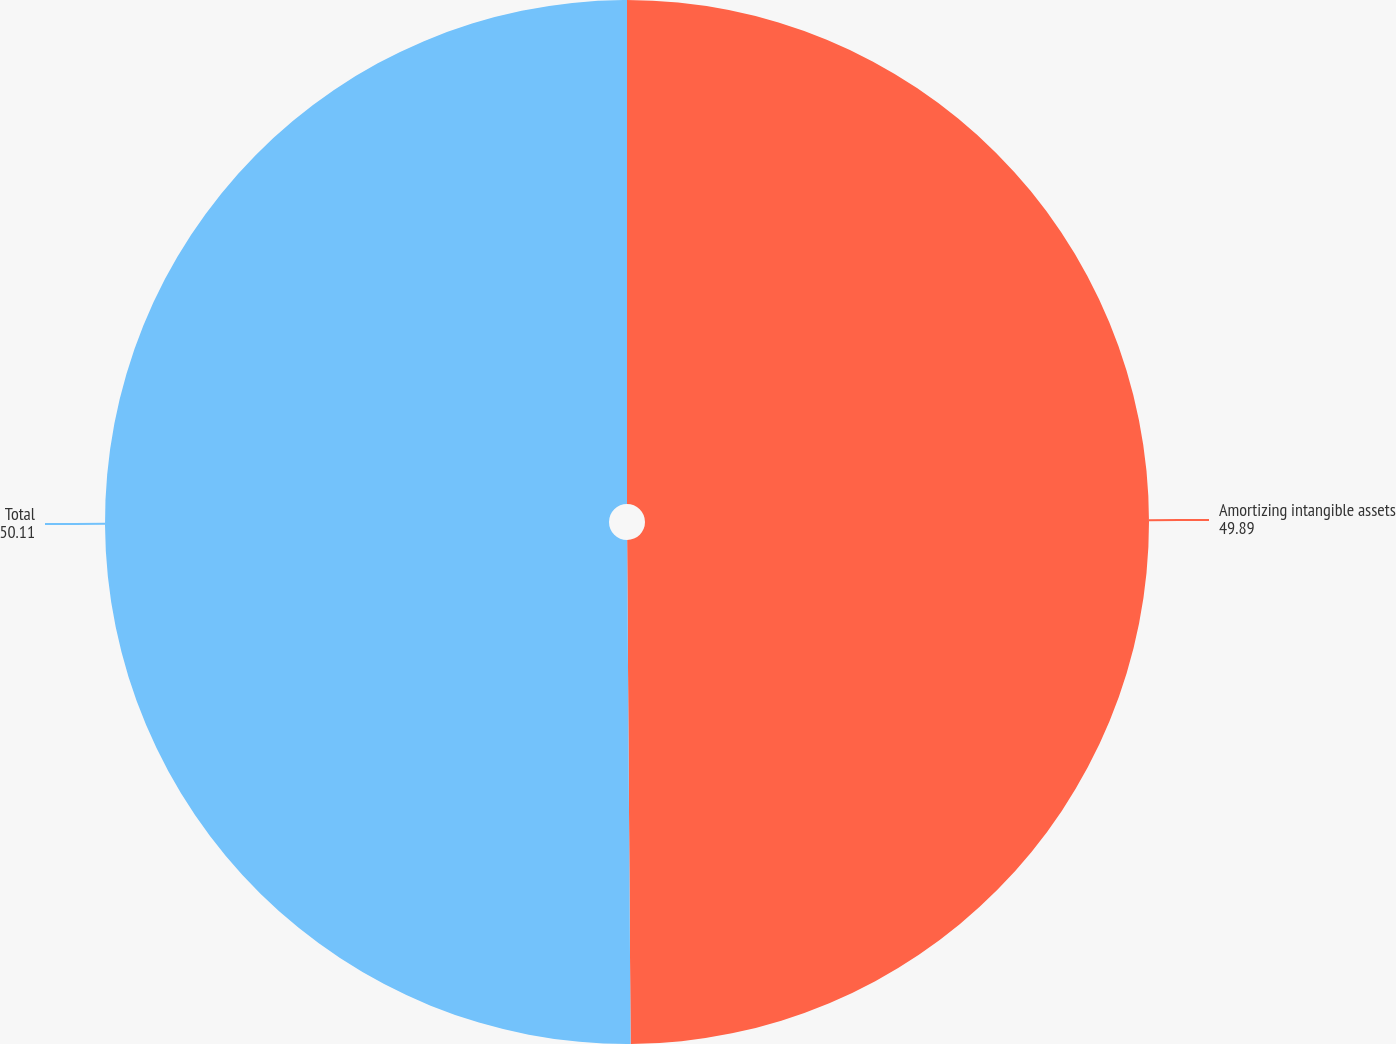Convert chart. <chart><loc_0><loc_0><loc_500><loc_500><pie_chart><fcel>Amortizing intangible assets<fcel>Total<nl><fcel>49.89%<fcel>50.11%<nl></chart> 